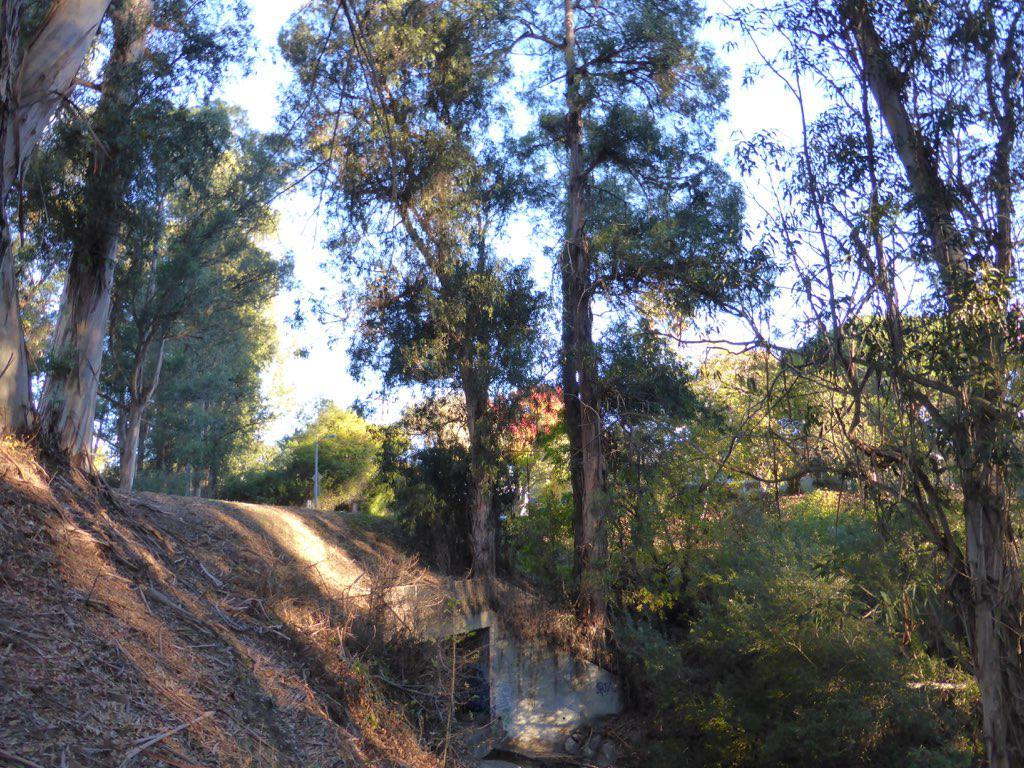What is the primary feature of the image? There are many trees in the image. Can you describe the landscape in the image? The landscape is dominated by trees. What type of environment might this image depict? The image might depict a forest or wooded area. What type of bean is being discussed in the meeting in the image? There is no meeting or bean present in the image; it only features trees. 